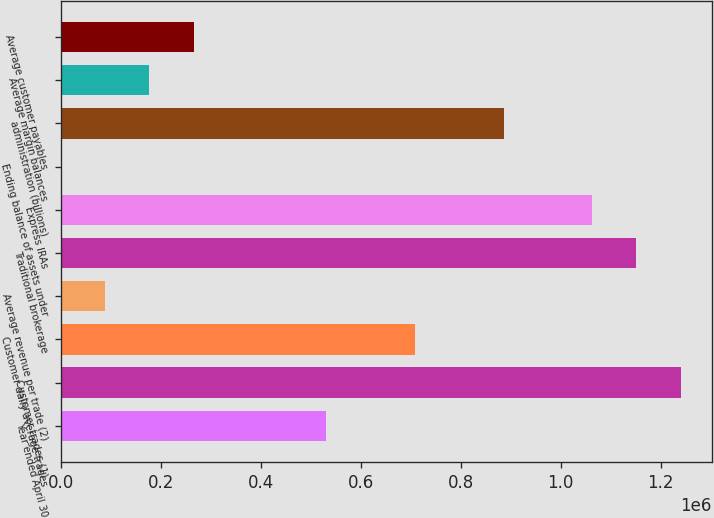<chart> <loc_0><loc_0><loc_500><loc_500><bar_chart><fcel>Year ended April 30<fcel>Customer trades (1)<fcel>Customer daily average trades<fcel>Average revenue per trade (2)<fcel>Traditional brokerage<fcel>Express IRAs<fcel>Ending balance of assets under<fcel>administration (billions)<fcel>Average margin balances<fcel>Average customer payables<nl><fcel>531489<fcel>1.2401e+06<fcel>708642<fcel>88604.6<fcel>1.15153e+06<fcel>1.06295e+06<fcel>27.8<fcel>885796<fcel>177181<fcel>265758<nl></chart> 